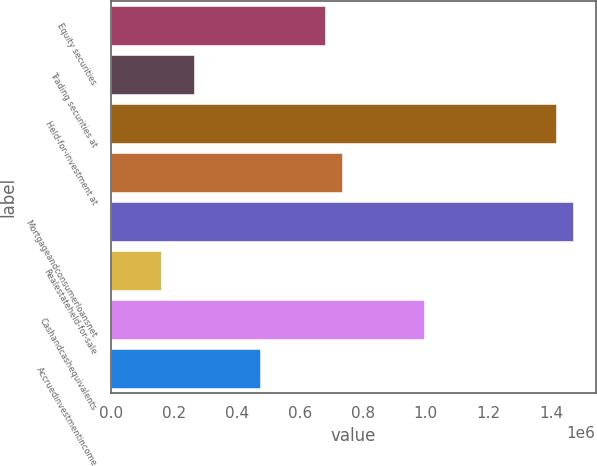Convert chart. <chart><loc_0><loc_0><loc_500><loc_500><bar_chart><fcel>Equity securities<fcel>Trading securities at<fcel>Held-for-investment at<fcel>Unnamed: 3<fcel>Mortgageandconsumerloansnet<fcel>Realestateheld-for-sale<fcel>Cashandcashequivalents<fcel>Accruedinvestmentincome<nl><fcel>681161<fcel>261986<fcel>1.41472e+06<fcel>733558<fcel>1.46711e+06<fcel>157192<fcel>995542<fcel>471573<nl></chart> 